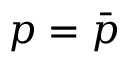<formula> <loc_0><loc_0><loc_500><loc_500>p = \bar { p }</formula> 